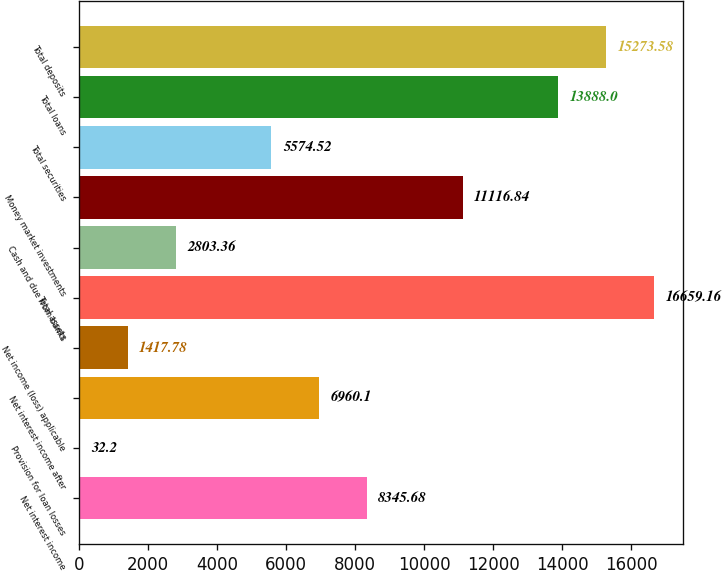Convert chart to OTSL. <chart><loc_0><loc_0><loc_500><loc_500><bar_chart><fcel>Net interest income<fcel>Provision for loan losses<fcel>Net interest income after<fcel>Net income (loss) applicable<fcel>Total assets<fcel>Cash and due from banks<fcel>Money market investments<fcel>Total securities<fcel>Total loans<fcel>Total deposits<nl><fcel>8345.68<fcel>32.2<fcel>6960.1<fcel>1417.78<fcel>16659.2<fcel>2803.36<fcel>11116.8<fcel>5574.52<fcel>13888<fcel>15273.6<nl></chart> 